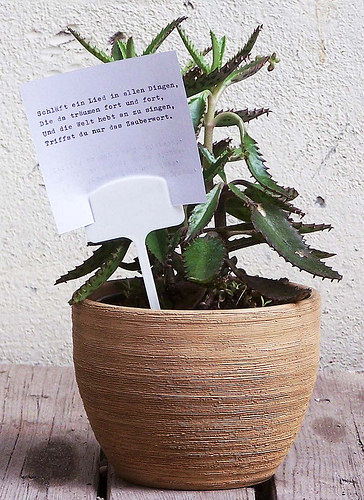<image>
Can you confirm if the paper is in the pot? Yes. The paper is contained within or inside the pot, showing a containment relationship. 